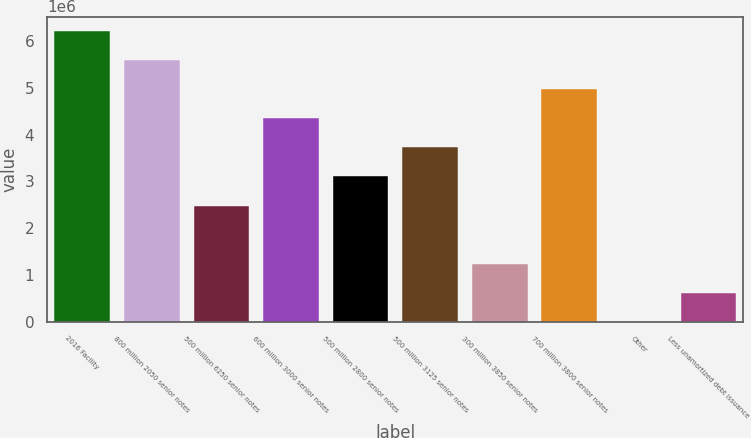<chart> <loc_0><loc_0><loc_500><loc_500><bar_chart><fcel>2016 Facility<fcel>800 million 2050 senior notes<fcel>500 million 6250 senior notes<fcel>600 million 3000 senior notes<fcel>500 million 2800 senior notes<fcel>500 million 3125 senior notes<fcel>300 million 3850 senior notes<fcel>700 million 3800 senior notes<fcel>Other<fcel>Less unamortized debt issuance<nl><fcel>6.20954e+06<fcel>5.58888e+06<fcel>2.48561e+06<fcel>4.34757e+06<fcel>3.10626e+06<fcel>3.72692e+06<fcel>1.2443e+06<fcel>4.96823e+06<fcel>2989<fcel>623644<nl></chart> 